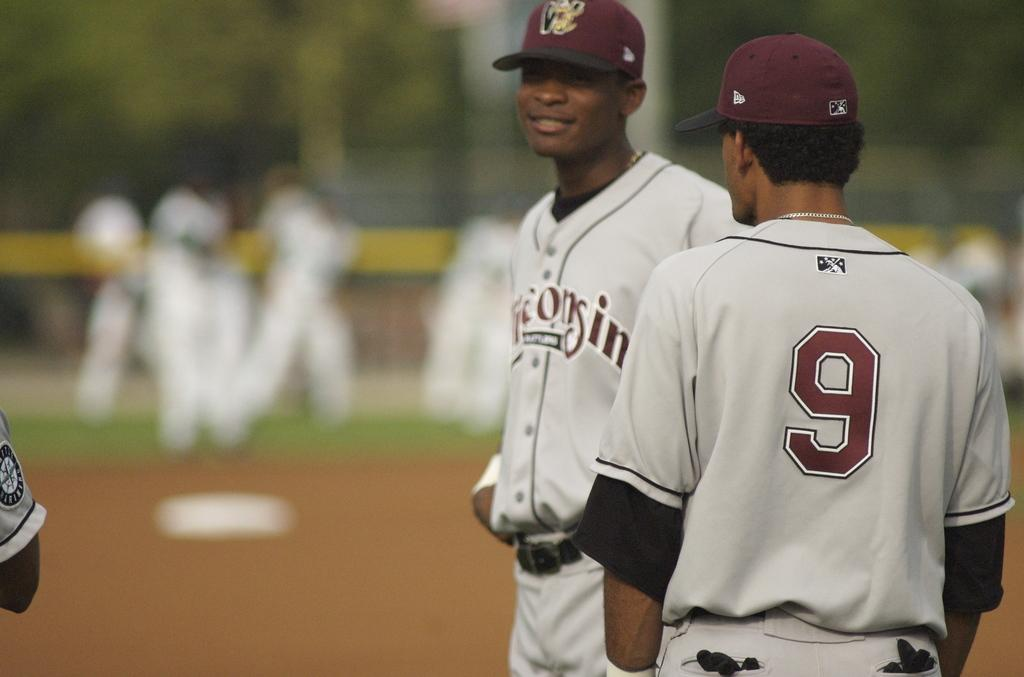<image>
Render a clear and concise summary of the photo. Player number 9 is standing next to one of his teammates on the field. 